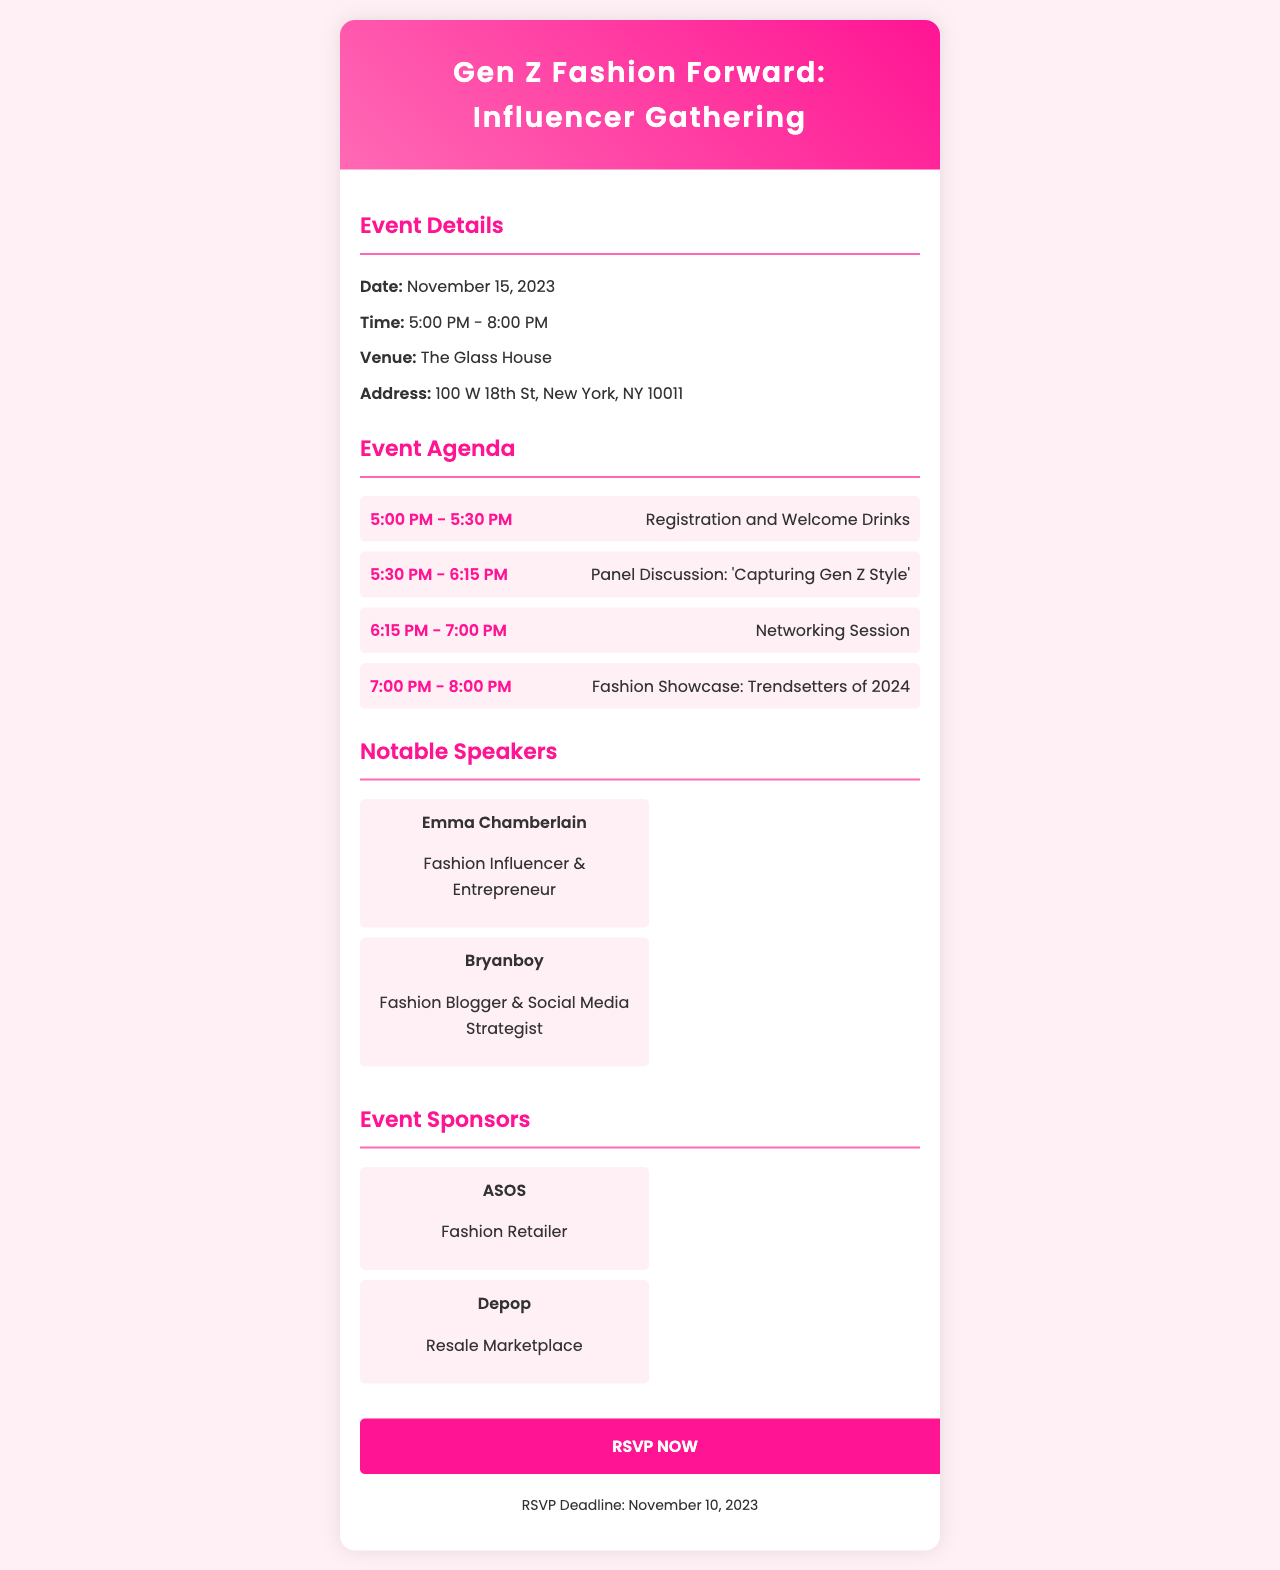What is the date of the event? The date of the event is provided in the document.
Answer: November 15, 2023 What time does the event start? The document specifies the start time for the event.
Answer: 5:00 PM Where is the venue located? The address for the venue is listed clearly in the document.
Answer: The Glass House, 100 W 18th St, New York, NY 10011 Who are the notable speakers at the event? The document names the speakers, including their roles.
Answer: Emma Chamberlain and Bryanboy What is the deadline to RSVP? The RSVP deadline is explicitly mentioned in the document.
Answer: November 10, 2023 What is the topic of the panel discussion? The agenda details the topic of the panel discussion.
Answer: 'Capturing Gen Z Style' How long is the networking session? The agenda indicates the duration of the networking session.
Answer: 45 minutes What type of companies are sponsoring the event? The document lists the sponsors along with their business types.
Answer: Fashion Retailer and Resale Marketplace What event activity happens after the networking session? The agenda outlines the activities scheduled for the event.
Answer: Fashion Showcase: Trendsetters of 2024 